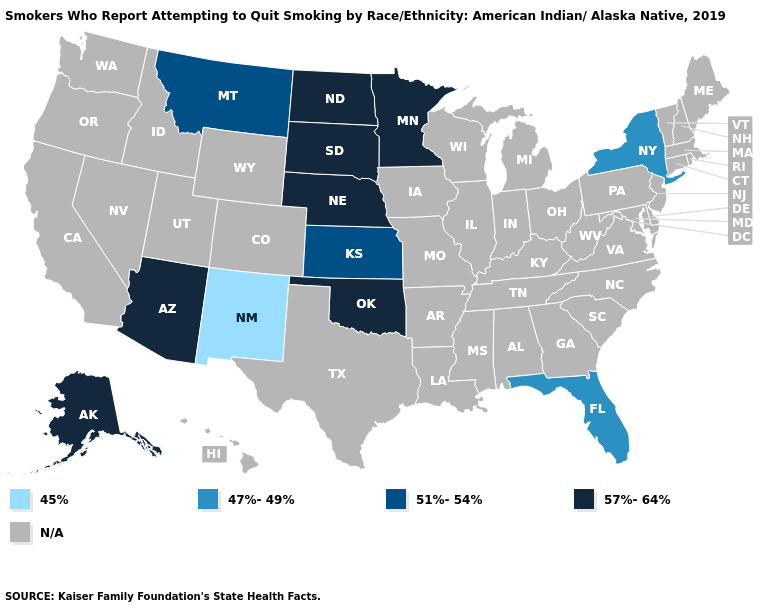What is the highest value in the USA?
Short answer required. 57%-64%. Name the states that have a value in the range 45%?
Concise answer only. New Mexico. Which states hav the highest value in the MidWest?
Quick response, please. Minnesota, Nebraska, North Dakota, South Dakota. What is the value of New Jersey?
Answer briefly. N/A. What is the highest value in the Northeast ?
Answer briefly. 47%-49%. Which states have the lowest value in the West?
Quick response, please. New Mexico. Name the states that have a value in the range 45%?
Short answer required. New Mexico. What is the lowest value in the USA?
Answer briefly. 45%. Does South Dakota have the highest value in the USA?
Concise answer only. Yes. Name the states that have a value in the range 57%-64%?
Write a very short answer. Alaska, Arizona, Minnesota, Nebraska, North Dakota, Oklahoma, South Dakota. Name the states that have a value in the range 47%-49%?
Quick response, please. Florida, New York. What is the highest value in the South ?
Write a very short answer. 57%-64%. Does New York have the highest value in the USA?
Write a very short answer. No. 